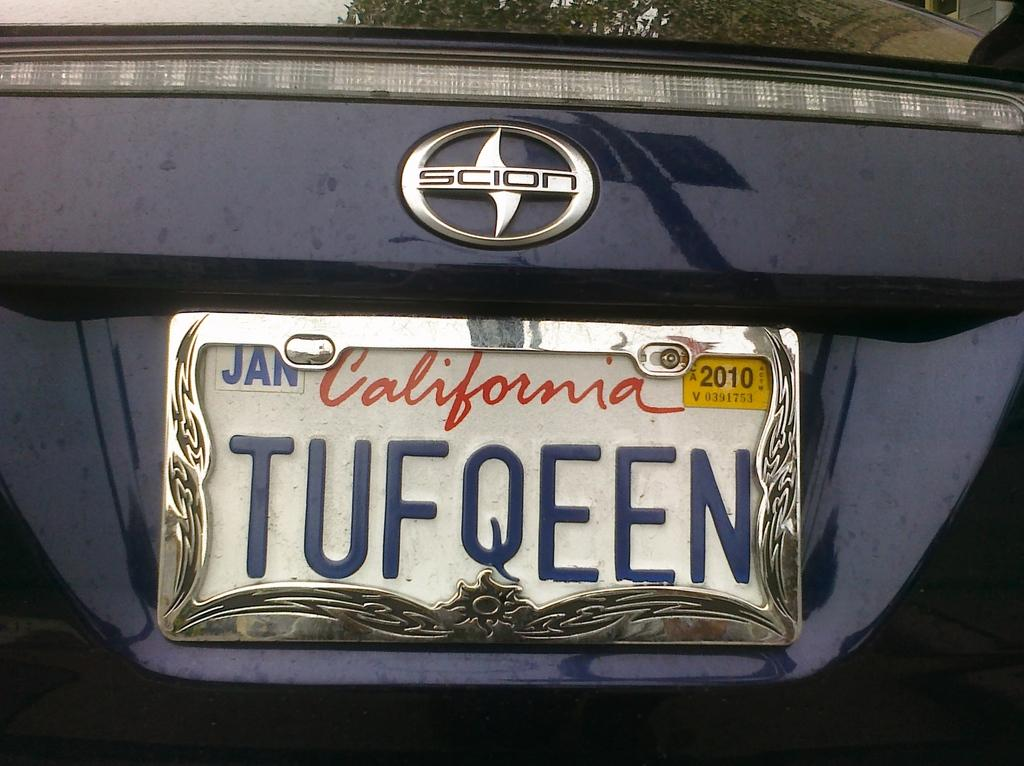<image>
Render a clear and concise summary of the photo. A license plate on a Scion is from California. 